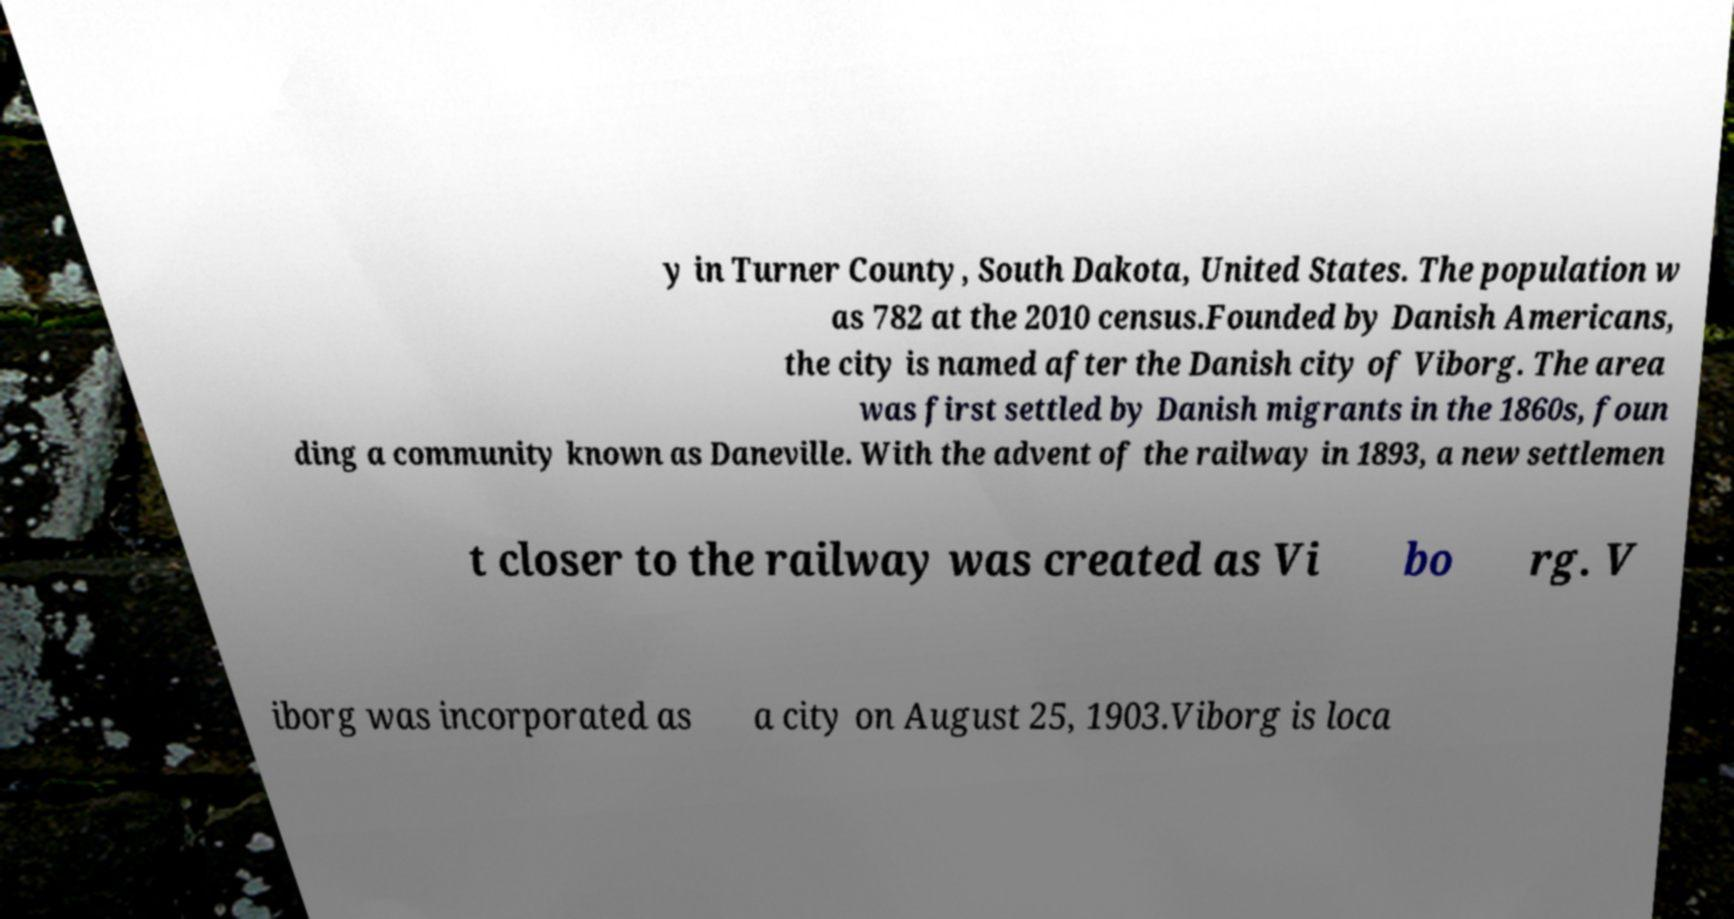Please identify and transcribe the text found in this image. y in Turner County, South Dakota, United States. The population w as 782 at the 2010 census.Founded by Danish Americans, the city is named after the Danish city of Viborg. The area was first settled by Danish migrants in the 1860s, foun ding a community known as Daneville. With the advent of the railway in 1893, a new settlemen t closer to the railway was created as Vi bo rg. V iborg was incorporated as a city on August 25, 1903.Viborg is loca 